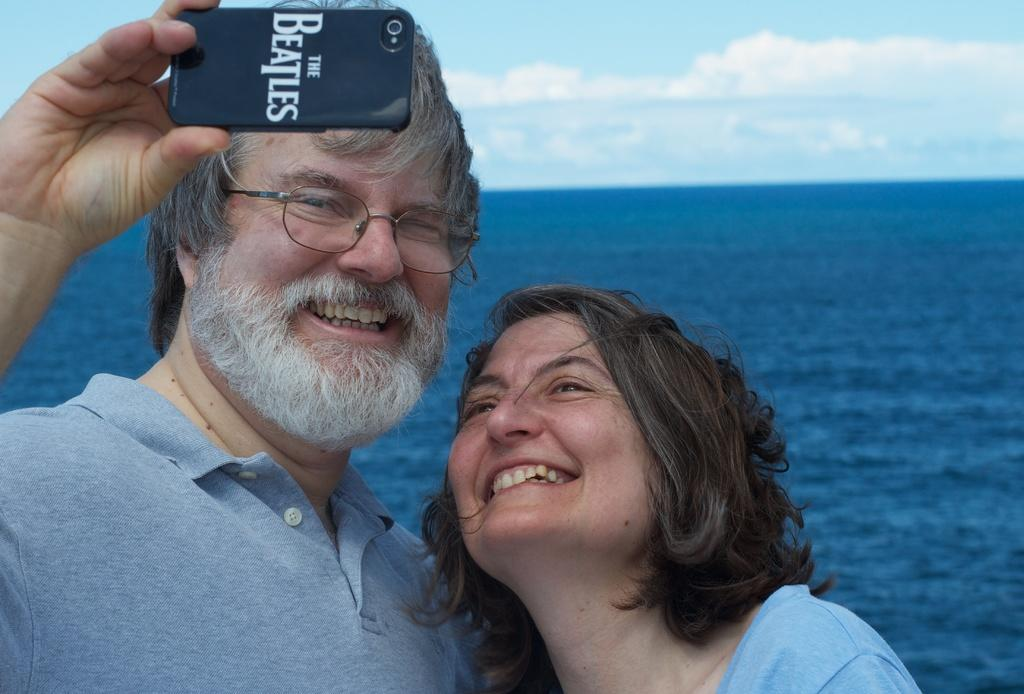What is the main subject of the image? There is a man in the image. What is the man holding in his hand? The man is holding a mobile in his hand. Can you describe the man's appearance? The man is wearing glasses. Who is standing near the man? There is a woman standing near the man. What can be seen in the background of the image? There is a sea and sky visible in the background of the image. How many toes can be seen on the man's feet in the image? There is no visible indication of the man's feet in the image, so the number of toes cannot be determined. 